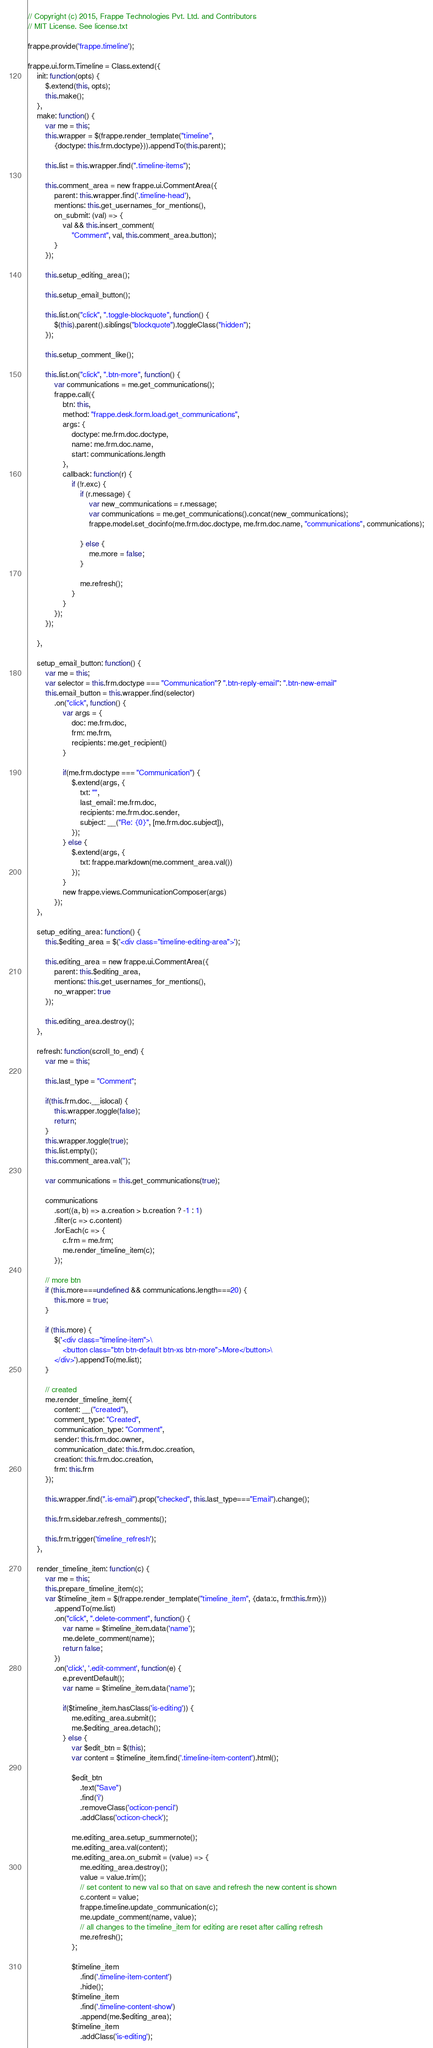Convert code to text. <code><loc_0><loc_0><loc_500><loc_500><_JavaScript_>// Copyright (c) 2015, Frappe Technologies Pvt. Ltd. and Contributors
// MIT License. See license.txt

frappe.provide('frappe.timeline');

frappe.ui.form.Timeline = Class.extend({
	init: function(opts) {
		$.extend(this, opts);
		this.make();
	},
	make: function() {
		var me = this;
		this.wrapper = $(frappe.render_template("timeline",
			{doctype: this.frm.doctype})).appendTo(this.parent);

		this.list = this.wrapper.find(".timeline-items");

		this.comment_area = new frappe.ui.CommentArea({
			parent: this.wrapper.find('.timeline-head'),
			mentions: this.get_usernames_for_mentions(),
			on_submit: (val) => {
				val && this.insert_comment(
					"Comment", val, this.comment_area.button);
			}
		});

		this.setup_editing_area();

		this.setup_email_button();

		this.list.on("click", ".toggle-blockquote", function() {
			$(this).parent().siblings("blockquote").toggleClass("hidden");
		});

		this.setup_comment_like();

		this.list.on("click", ".btn-more", function() {
			var communications = me.get_communications();
			frappe.call({
				btn: this,
				method: "frappe.desk.form.load.get_communications",
				args: {
					doctype: me.frm.doc.doctype,
					name: me.frm.doc.name,
					start: communications.length
				},
				callback: function(r) {
					if (!r.exc) {
						if (r.message) {
							var new_communications = r.message;
							var communications = me.get_communications().concat(new_communications);
							frappe.model.set_docinfo(me.frm.doc.doctype, me.frm.doc.name, "communications", communications);

						} else {
							me.more = false;
						}

						me.refresh();
					}
				}
			});
		});

	},

	setup_email_button: function() {
		var me = this;
		var selector = this.frm.doctype === "Communication"? ".btn-reply-email": ".btn-new-email"
		this.email_button = this.wrapper.find(selector)
			.on("click", function() {
				var args = {
					doc: me.frm.doc,
					frm: me.frm,
					recipients: me.get_recipient()
				}

				if(me.frm.doctype === "Communication") {
					$.extend(args, {
						txt: "",
						last_email: me.frm.doc,
						recipients: me.frm.doc.sender,
						subject: __("Re: {0}", [me.frm.doc.subject]),
					});
				} else {
					$.extend(args, {
						txt: frappe.markdown(me.comment_area.val())
					});
				}
				new frappe.views.CommunicationComposer(args)
			});
	},

	setup_editing_area: function() {
		this.$editing_area = $('<div class="timeline-editing-area">');

		this.editing_area = new frappe.ui.CommentArea({
			parent: this.$editing_area,
			mentions: this.get_usernames_for_mentions(),
			no_wrapper: true
		});

		this.editing_area.destroy();
	},

	refresh: function(scroll_to_end) {
		var me = this;

		this.last_type = "Comment";

		if(this.frm.doc.__islocal) {
			this.wrapper.toggle(false);
			return;
		}
		this.wrapper.toggle(true);
		this.list.empty();
		this.comment_area.val('');

		var communications = this.get_communications(true);

		communications
			.sort((a, b) => a.creation > b.creation ? -1 : 1)
			.filter(c => c.content)
			.forEach(c => {
				c.frm = me.frm;
				me.render_timeline_item(c);
			});

		// more btn
		if (this.more===undefined && communications.length===20) {
			this.more = true;
		}

		if (this.more) {
			$('<div class="timeline-item">\
				<button class="btn btn-default btn-xs btn-more">More</button>\
			</div>').appendTo(me.list);
		}

		// created
		me.render_timeline_item({
			content: __("created"),
			comment_type: "Created",
			communication_type: "Comment",
			sender: this.frm.doc.owner,
			communication_date: this.frm.doc.creation,
			creation: this.frm.doc.creation,
			frm: this.frm
		});

		this.wrapper.find(".is-email").prop("checked", this.last_type==="Email").change();

		this.frm.sidebar.refresh_comments();

		this.frm.trigger('timeline_refresh');
	},

	render_timeline_item: function(c) {
		var me = this;
		this.prepare_timeline_item(c);
		var $timeline_item = $(frappe.render_template("timeline_item", {data:c, frm:this.frm}))
			.appendTo(me.list)
			.on("click", ".delete-comment", function() {
				var name = $timeline_item.data('name');
				me.delete_comment(name);
				return false;
			})
			.on('click', '.edit-comment', function(e) {
				e.preventDefault();
				var name = $timeline_item.data('name');

				if($timeline_item.hasClass('is-editing')) {
					me.editing_area.submit();
					me.$editing_area.detach();
				} else {
					var $edit_btn = $(this);
					var content = $timeline_item.find('.timeline-item-content').html();

					$edit_btn
						.text("Save")
						.find('i')
						.removeClass('octicon-pencil')
						.addClass('octicon-check');

					me.editing_area.setup_summernote();
					me.editing_area.val(content);
					me.editing_area.on_submit = (value) => {
						me.editing_area.destroy();
						value = value.trim();
						// set content to new val so that on save and refresh the new content is shown
						c.content = value;
						frappe.timeline.update_communication(c);
						me.update_comment(name, value);
						// all changes to the timeline_item for editing are reset after calling refresh
						me.refresh();
					};

					$timeline_item
						.find('.timeline-item-content')
						.hide();
					$timeline_item
						.find('.timeline-content-show')
						.append(me.$editing_area);
					$timeline_item
						.addClass('is-editing');</code> 